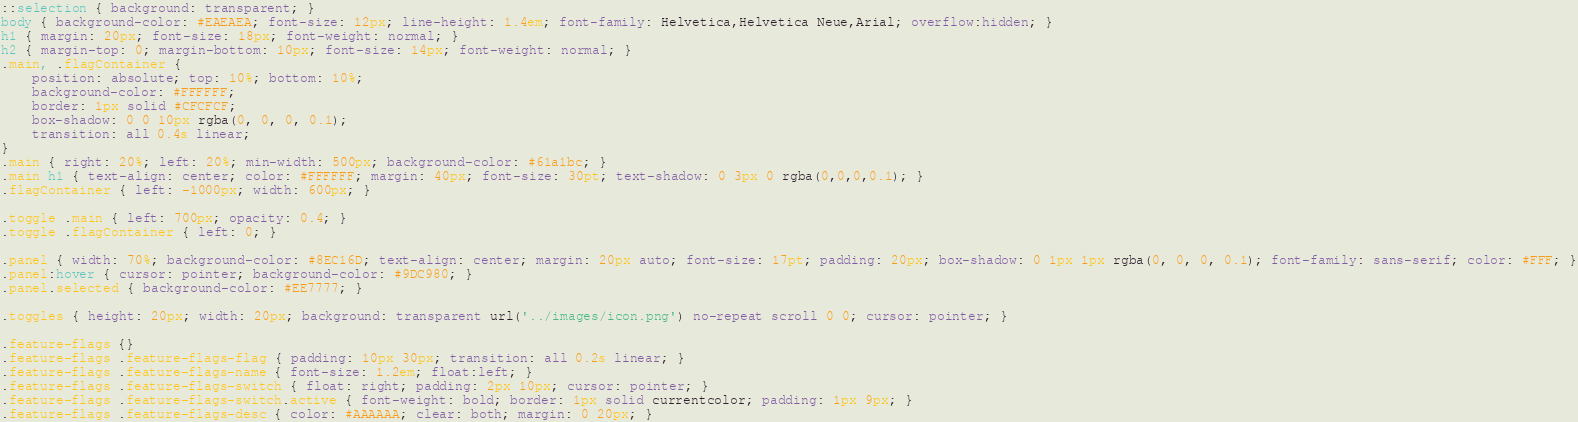<code> <loc_0><loc_0><loc_500><loc_500><_CSS_>::selection { background: transparent; }
body { background-color: #EAEAEA; font-size: 12px; line-height: 1.4em; font-family: Helvetica,Helvetica Neue,Arial; overflow:hidden; }
h1 { margin: 20px; font-size: 18px; font-weight: normal; }
h2 { margin-top: 0; margin-bottom: 10px; font-size: 14px; font-weight: normal; }
.main, .flagContainer {
    position: absolute; top: 10%; bottom: 10%;
    background-color: #FFFFFF;
    border: 1px solid #CFCFCF;
    box-shadow: 0 0 10px rgba(0, 0, 0, 0.1);
    transition: all 0.4s linear;
}
.main { right: 20%; left: 20%; min-width: 500px; background-color: #61a1bc; }
.main h1 { text-align: center; color: #FFFFFF; margin: 40px; font-size: 30pt; text-shadow: 0 3px 0 rgba(0,0,0,0.1); }
.flagContainer { left: -1000px; width: 600px; }

.toggle .main { left: 700px; opacity: 0.4; }
.toggle .flagContainer { left: 0; }

.panel { width: 70%; background-color: #8EC16D; text-align: center; margin: 20px auto; font-size: 17pt; padding: 20px; box-shadow: 0 1px 1px rgba(0, 0, 0, 0.1); font-family: sans-serif; color: #FFF; }
.panel:hover { cursor: pointer; background-color: #9DC980; }
.panel.selected { background-color: #EE7777; }

.toggles { height: 20px; width: 20px; background: transparent url('../images/icon.png') no-repeat scroll 0 0; cursor: pointer; }

.feature-flags {}
.feature-flags .feature-flags-flag { padding: 10px 30px; transition: all 0.2s linear; }
.feature-flags .feature-flags-name { font-size: 1.2em; float:left; }
.feature-flags .feature-flags-switch { float: right; padding: 2px 10px; cursor: pointer; }
.feature-flags .feature-flags-switch.active { font-weight: bold; border: 1px solid currentcolor; padding: 1px 9px; }
.feature-flags .feature-flags-desc { color: #AAAAAA; clear: both; margin: 0 20px; }</code> 